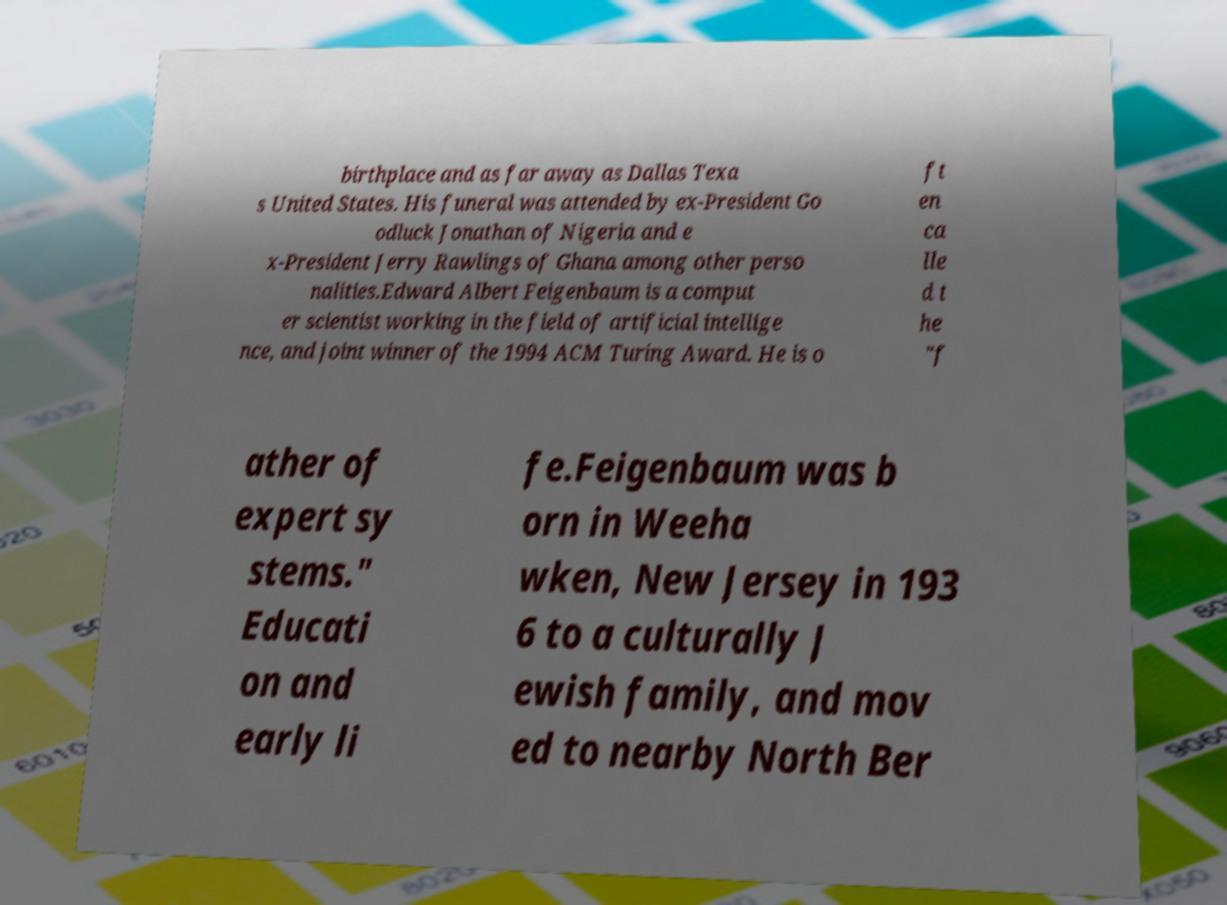For documentation purposes, I need the text within this image transcribed. Could you provide that? birthplace and as far away as Dallas Texa s United States. His funeral was attended by ex-President Go odluck Jonathan of Nigeria and e x-President Jerry Rawlings of Ghana among other perso nalities.Edward Albert Feigenbaum is a comput er scientist working in the field of artificial intellige nce, and joint winner of the 1994 ACM Turing Award. He is o ft en ca lle d t he "f ather of expert sy stems." Educati on and early li fe.Feigenbaum was b orn in Weeha wken, New Jersey in 193 6 to a culturally J ewish family, and mov ed to nearby North Ber 